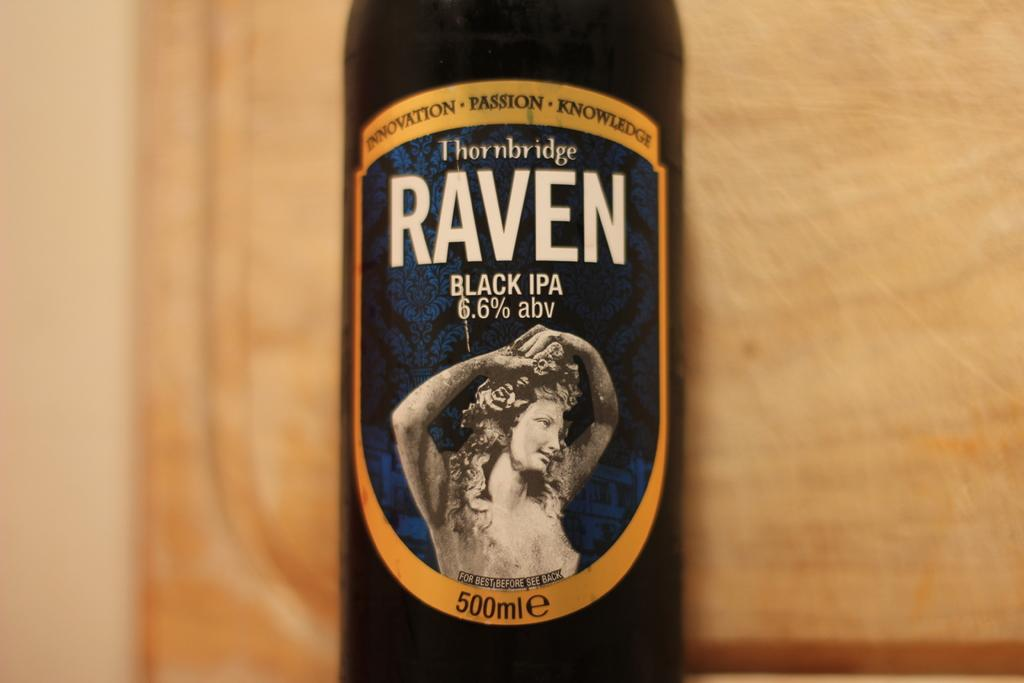<image>
Summarize the visual content of the image. Raven Black IPA contains 6.6% abv and is available in a 500mlE bottle. 